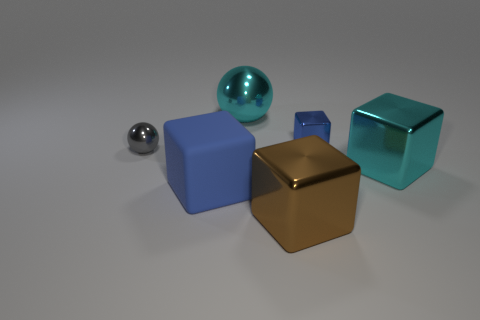Add 4 green shiny blocks. How many objects exist? 10 Subtract all brown shiny things. Subtract all shiny cubes. How many objects are left? 2 Add 2 large metal objects. How many large metal objects are left? 5 Add 5 small brown matte spheres. How many small brown matte spheres exist? 5 Subtract 1 cyan balls. How many objects are left? 5 Subtract all balls. How many objects are left? 4 